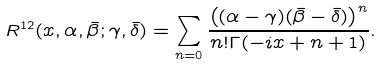Convert formula to latex. <formula><loc_0><loc_0><loc_500><loc_500>R ^ { 1 2 } ( x , \alpha , \bar { \beta } ; \gamma , \bar { \delta } ) = \sum _ { n = 0 } \frac { \left ( ( \alpha - \gamma ) ( \bar { \beta } - \bar { \delta } ) \right ) ^ { n } } { n ! \Gamma ( - i x + n + 1 ) } .</formula> 